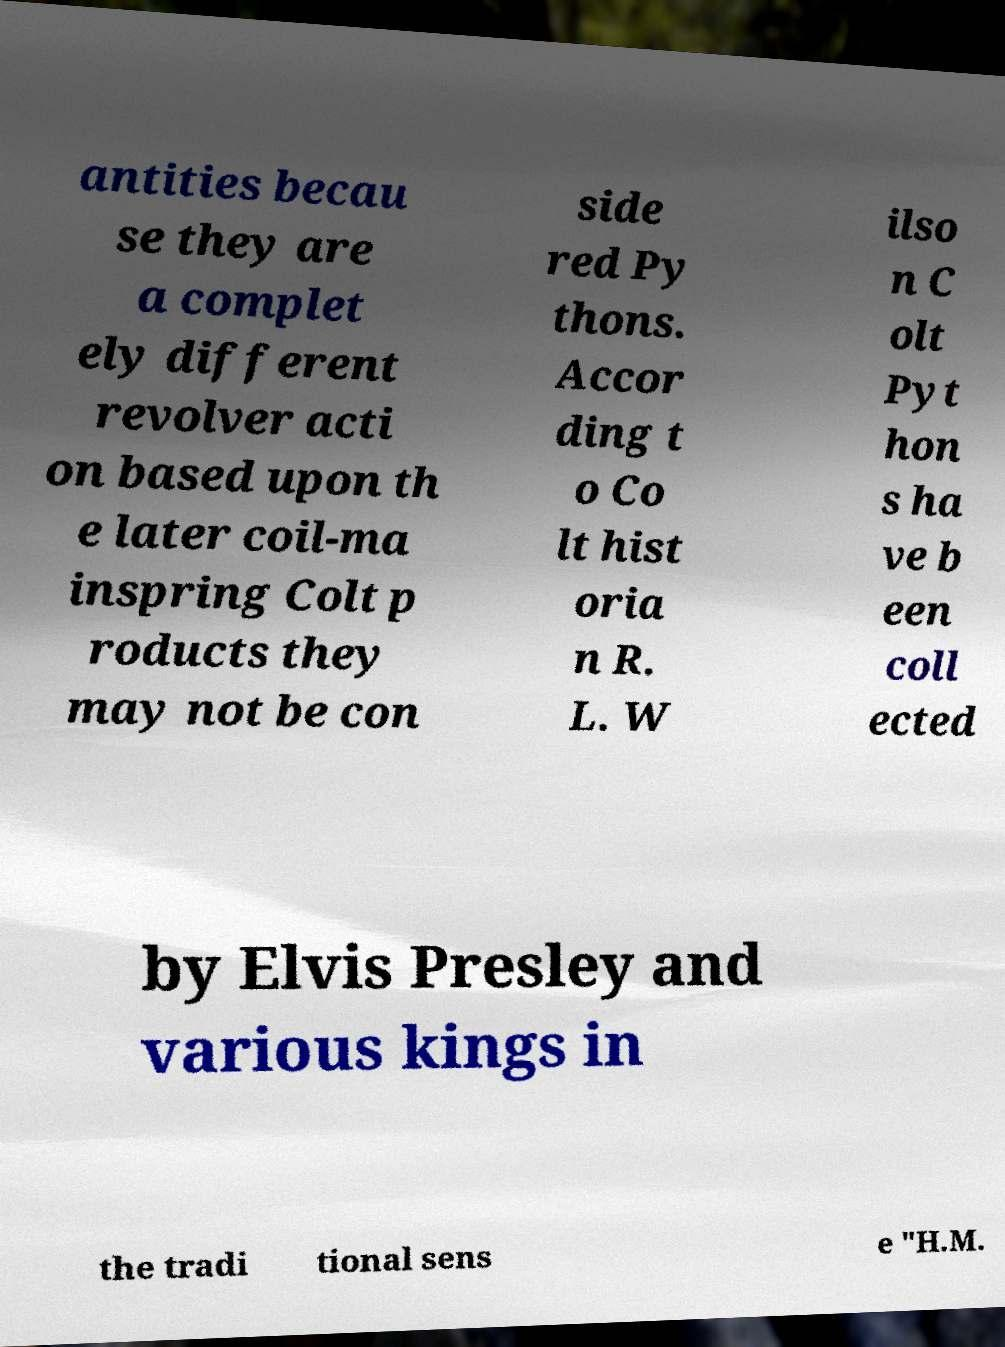What messages or text are displayed in this image? I need them in a readable, typed format. antities becau se they are a complet ely different revolver acti on based upon th e later coil-ma inspring Colt p roducts they may not be con side red Py thons. Accor ding t o Co lt hist oria n R. L. W ilso n C olt Pyt hon s ha ve b een coll ected by Elvis Presley and various kings in the tradi tional sens e "H.M. 